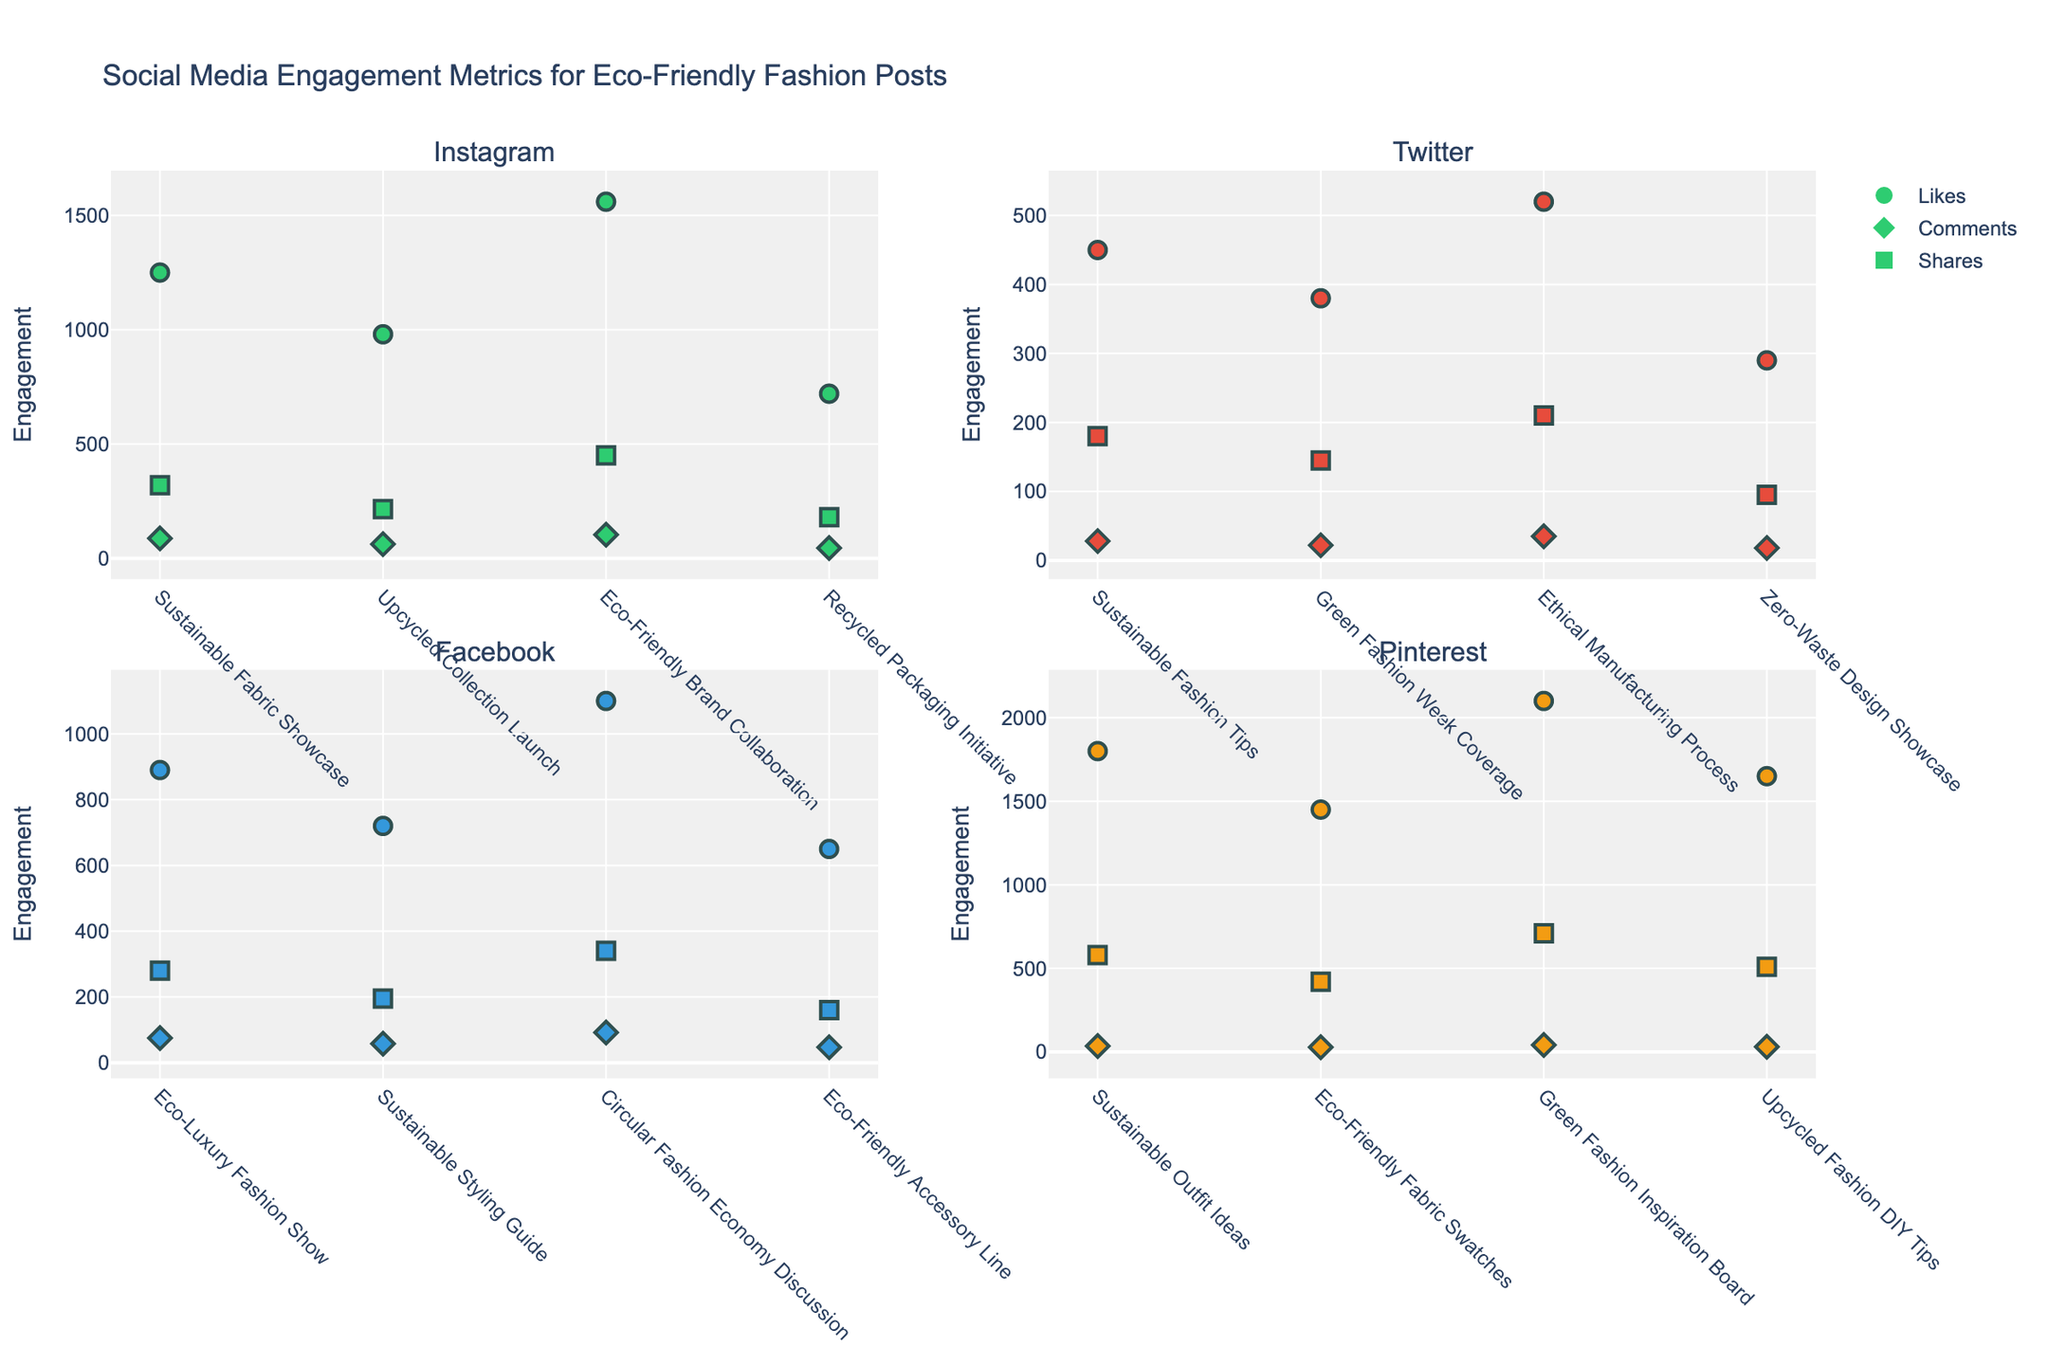What is the title of the plot? The title is usually displayed prominently at the top of the figure, making it easy to recognize.
Answer: Environmental Impact Mitigation Investments by Sector (2020-2022) Which sector had the highest investment in 2022? Look for the tallest bar in the subplots for the year 2022. The corresponding sector is the answer.
Answer: Downstream How many companies are represented in each sector? Count the number of bars in one year's subplot for any sector. Each bar represents one company. Repeat this for another sector to confirm consistency.
Answer: Two What is the investment of ExxonMobil in 2021? Find the "Upstream" sector and locate ExxonMobil. The height of the bar labeled with 2021’s color gives the investment.
Answer: $520M By how much did Chevron's investment increase from 2020 to 2022? Locate Chevron in the "Upstream" sector. Calculate the difference between the investment amounts for 2020 and 2022. Chevron's investments were $380M in 2020 and $505M in 2022.
Answer: $125M Which sector has the most consistent annual investment growth from 2020 to 2022? Compare the bar heights across the years for each sector. Consistent growth means all bars increase steadily.
Answer: Integrated In which year did Kinder Morgan have the lowest investment? Look within the "Midstream" sector for Kinder Morgan. Identify the shortest bar among the three years for Kinder Morgan.
Answer: 2020 Which company had the largest investment in 2020 within the "Downstream" sector? Focus on the "Downstream" sector. Compare the heights of the bars labeled 2020 for Shell and BP.
Answer: Shell What was Halliburton's average annual investment from 2020 to 2022? Locate Halliburton in the "Oilfield Services" sector. Sum the investments for 2020, 2021, and 2022, then divide by three. Investments are $130M, $155M, and $185M. (130 + 155 + 185) / 3 = 156.67
Answer: $156.67M Which company in the "Integrated" sector invested more in 2022, TotalEnergies or ConocoPhillips? Identify the tallest bar in 2022 within the "Integrated" sector and compare the two companies.
Answer: TotalEnergies 